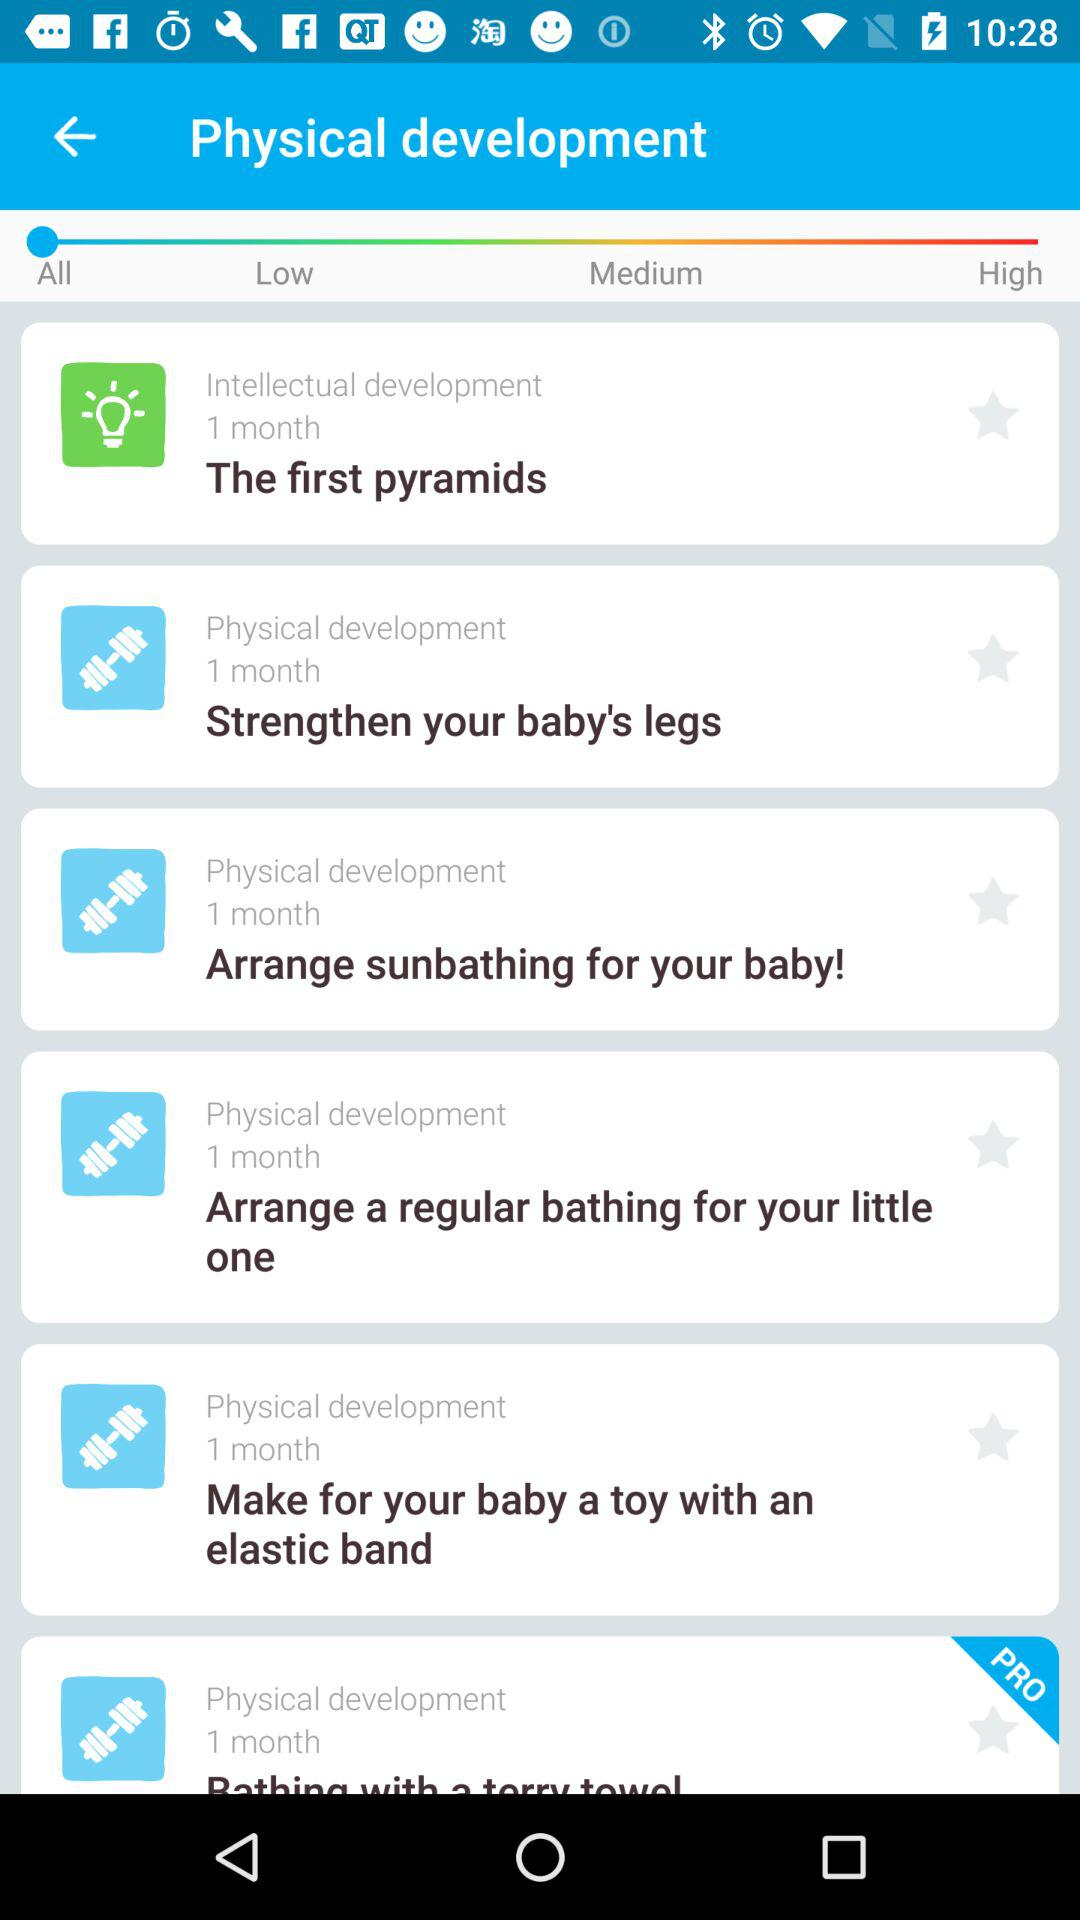How many of the tasks have a difficulty level of 'Pro'?
Answer the question using a single word or phrase. 1 